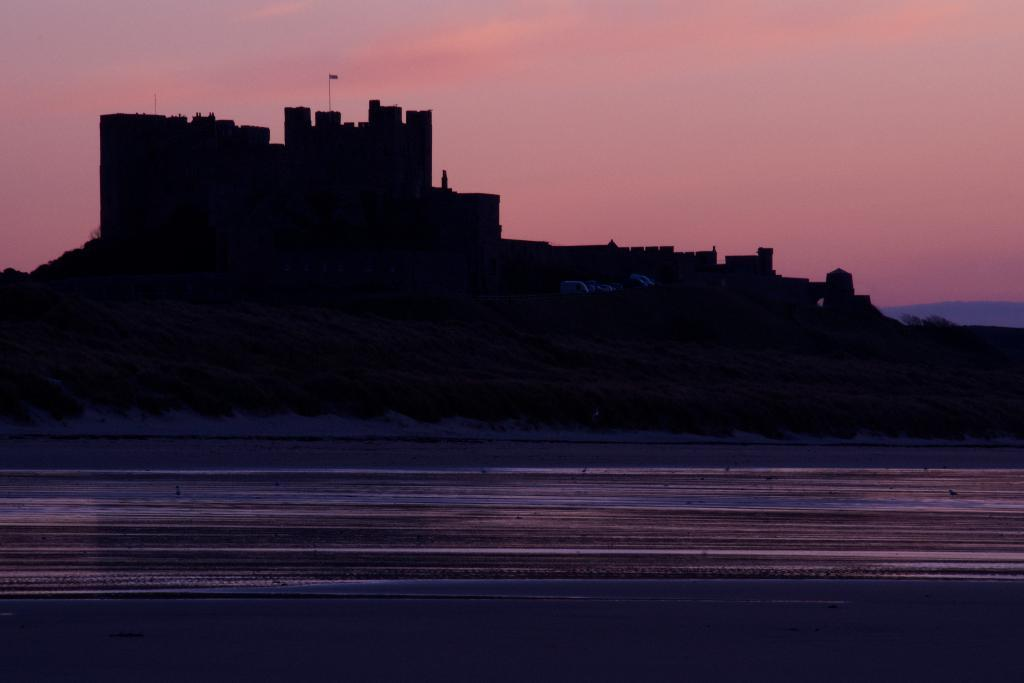What type of pathway can be seen in the image? There is a road in the image. What type of structure is present in the image? There is a fort in the image. What is attached to the fort in the image? There is a flag in the image. What type of natural formation can be seen in the image? There are mountains in the image. What is visible in the background of the image? The sky is visible in the background of the image. What can be seen in the sky in the image? Clouds are present in the sky. What type of precipitation can be seen falling from the sky in the image? There is no precipitation visible in the image; only clouds are present in the sky. What type of angle is the fort built at in the image? The image does not provide information about the angle at which the fort is built. 